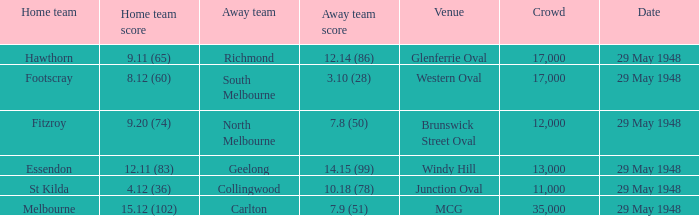In the match where footscray was the home team, how much did they score? 8.12 (60). 